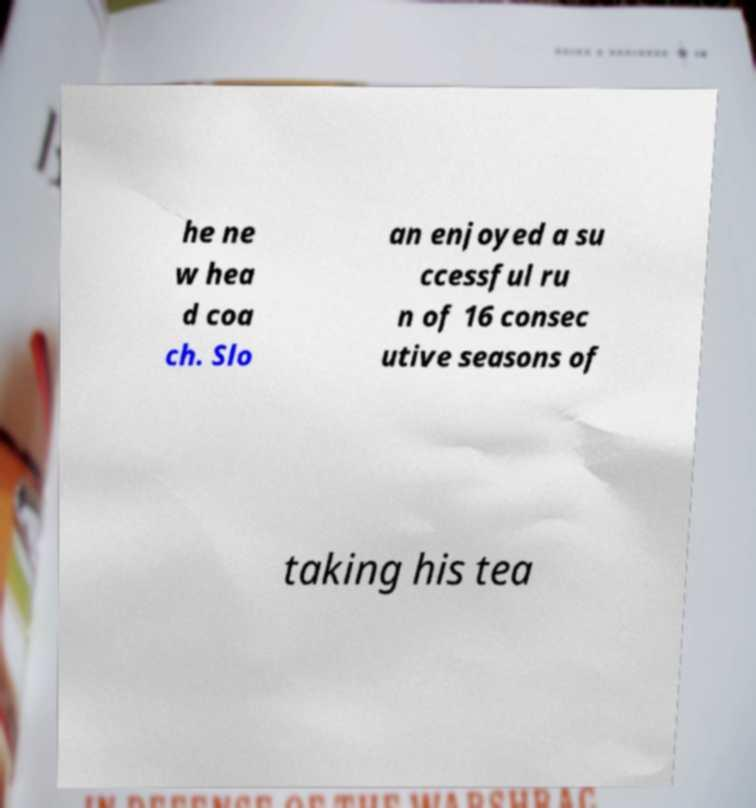Please identify and transcribe the text found in this image. he ne w hea d coa ch. Slo an enjoyed a su ccessful ru n of 16 consec utive seasons of taking his tea 